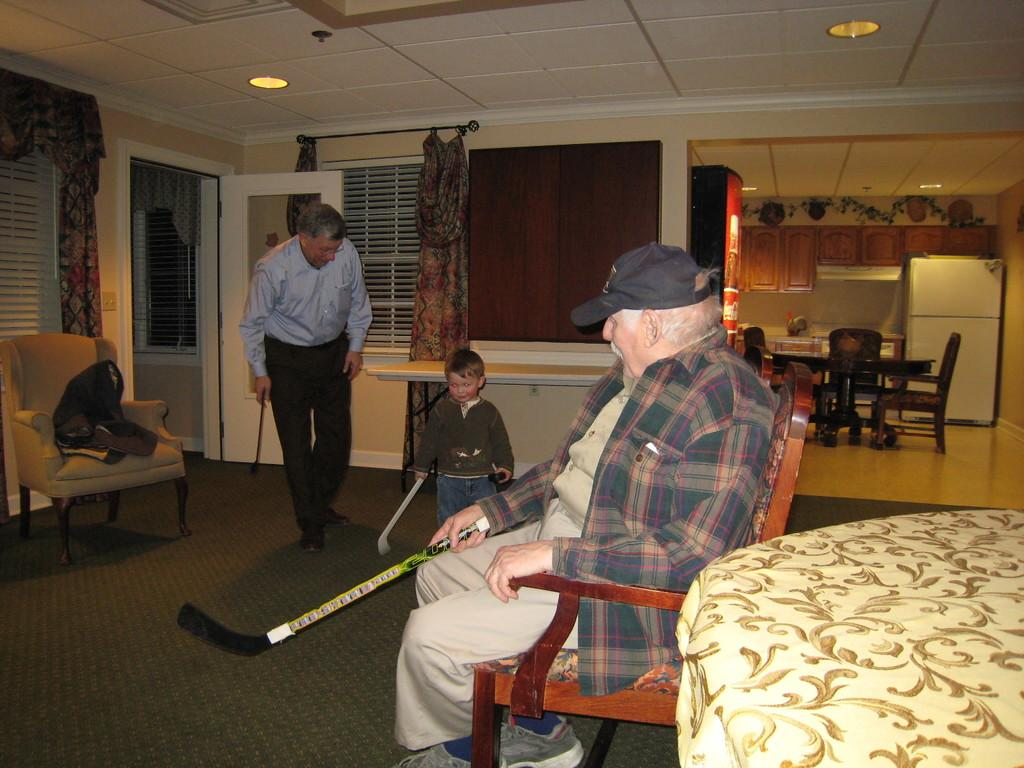What is the seated person doing in the image? The seated person is holding a hockey stick. How many hockey sticks are visible in the image? There are three hockey sticks visible in the image, one held by the seated person and one held by each of the standing persons. What are the standing persons doing in the image? The standing persons are each holding a hockey stick. What type of pizzas are being served to the brass band in the image? There is no mention of pizzas or a brass band in the image; it features a seated person and two standing persons, all holding hockey sticks. 